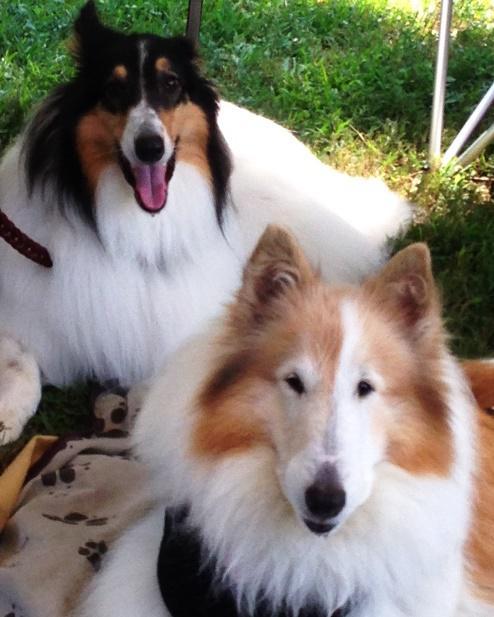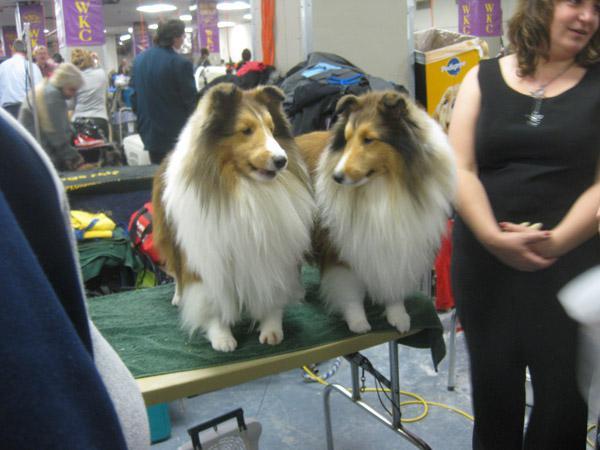The first image is the image on the left, the second image is the image on the right. For the images shown, is this caption "An image shows a woman in black next to at least one collie dog." true? Answer yes or no. Yes. The first image is the image on the left, the second image is the image on the right. Examine the images to the left and right. Is the description "One dog photo is taken outside in a grassy area, while the other is taken inside in a private home setting." accurate? Answer yes or no. No. 